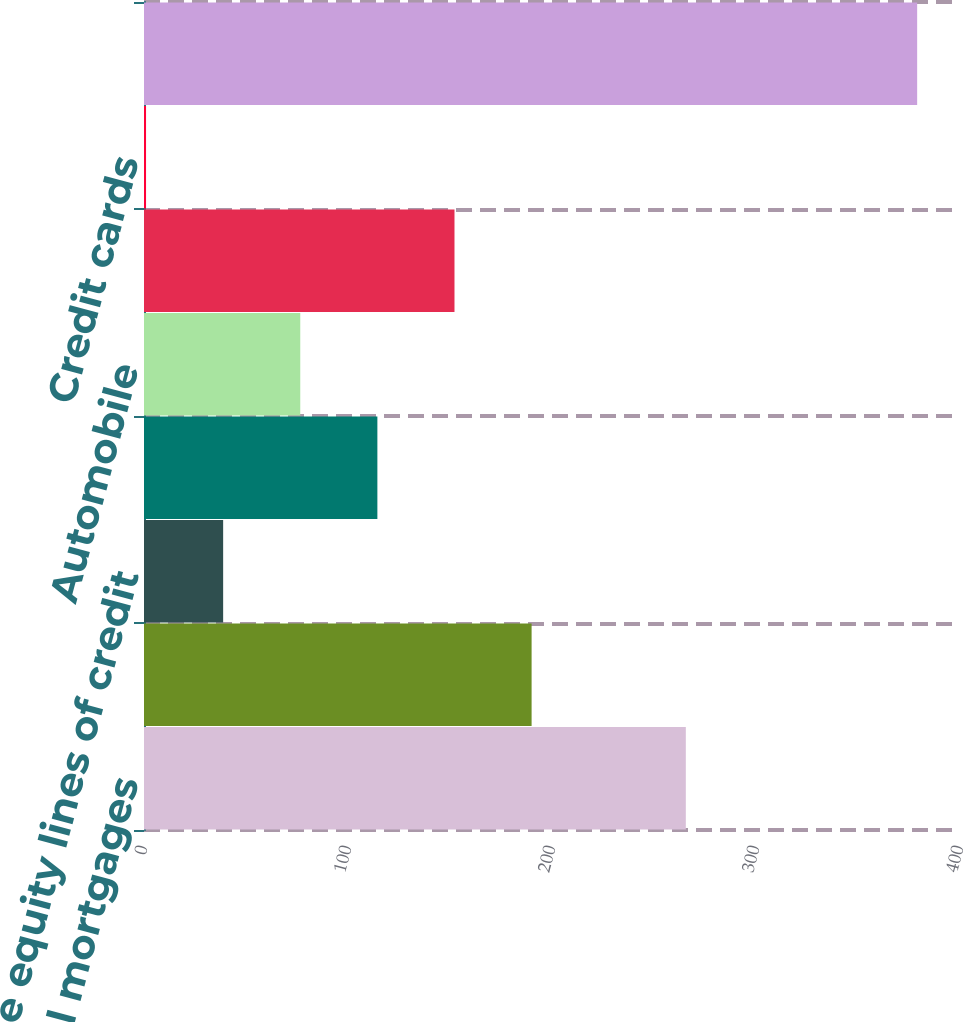Convert chart. <chart><loc_0><loc_0><loc_500><loc_500><bar_chart><fcel>Residential mortgages<fcel>Home equity loans<fcel>Home equity lines of credit<fcel>Home equity loans serviced by<fcel>Automobile<fcel>Student<fcel>Credit cards<fcel>Total<nl><fcel>265.6<fcel>190<fcel>38.8<fcel>114.4<fcel>76.6<fcel>152.2<fcel>1<fcel>379<nl></chart> 